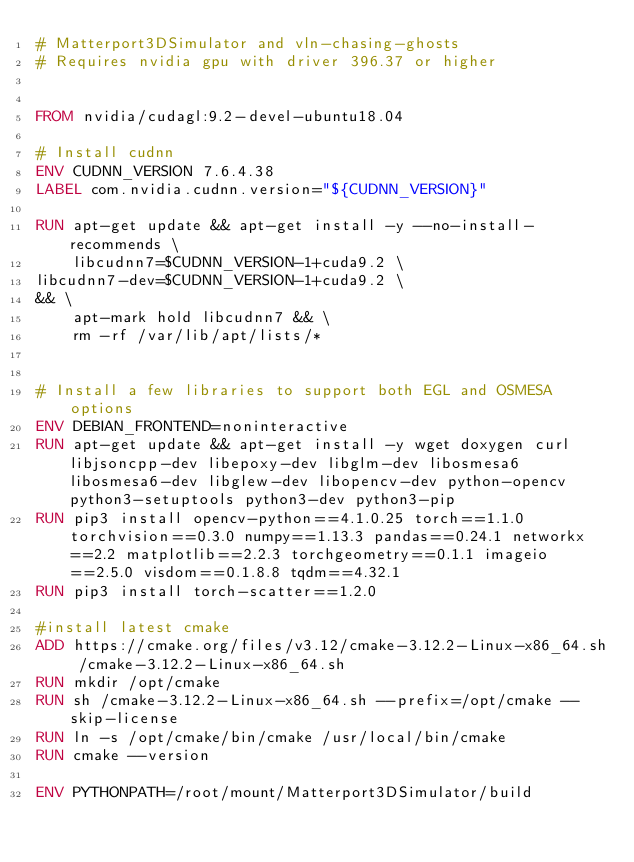<code> <loc_0><loc_0><loc_500><loc_500><_Dockerfile_># Matterport3DSimulator and vln-chasing-ghosts
# Requires nvidia gpu with driver 396.37 or higher


FROM nvidia/cudagl:9.2-devel-ubuntu18.04

# Install cudnn
ENV CUDNN_VERSION 7.6.4.38
LABEL com.nvidia.cudnn.version="${CUDNN_VERSION}"

RUN apt-get update && apt-get install -y --no-install-recommends \
    libcudnn7=$CUDNN_VERSION-1+cuda9.2 \
libcudnn7-dev=$CUDNN_VERSION-1+cuda9.2 \
&& \
    apt-mark hold libcudnn7 && \
    rm -rf /var/lib/apt/lists/*


# Install a few libraries to support both EGL and OSMESA options
ENV DEBIAN_FRONTEND=noninteractive
RUN apt-get update && apt-get install -y wget doxygen curl libjsoncpp-dev libepoxy-dev libglm-dev libosmesa6 libosmesa6-dev libglew-dev libopencv-dev python-opencv python3-setuptools python3-dev python3-pip
RUN pip3 install opencv-python==4.1.0.25 torch==1.1.0 torchvision==0.3.0 numpy==1.13.3 pandas==0.24.1 networkx==2.2 matplotlib==2.2.3 torchgeometry==0.1.1 imageio==2.5.0 visdom==0.1.8.8 tqdm==4.32.1
RUN pip3 install torch-scatter==1.2.0

#install latest cmake
ADD https://cmake.org/files/v3.12/cmake-3.12.2-Linux-x86_64.sh /cmake-3.12.2-Linux-x86_64.sh
RUN mkdir /opt/cmake
RUN sh /cmake-3.12.2-Linux-x86_64.sh --prefix=/opt/cmake --skip-license
RUN ln -s /opt/cmake/bin/cmake /usr/local/bin/cmake
RUN cmake --version

ENV PYTHONPATH=/root/mount/Matterport3DSimulator/build
</code> 